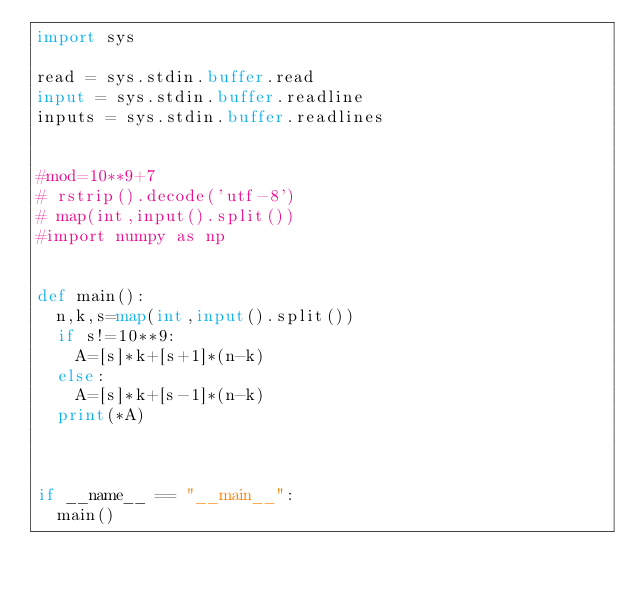Convert code to text. <code><loc_0><loc_0><loc_500><loc_500><_Python_>import sys

read = sys.stdin.buffer.read
input = sys.stdin.buffer.readline
inputs = sys.stdin.buffer.readlines


#mod=10**9+7
# rstrip().decode('utf-8')
# map(int,input().split())
#import numpy as np


def main():
	n,k,s=map(int,input().split())
	if s!=10**9:
		A=[s]*k+[s+1]*(n-k)
	else:
		A=[s]*k+[s-1]*(n-k)
	print(*A)
	


if __name__ == "__main__":
	main()
</code> 